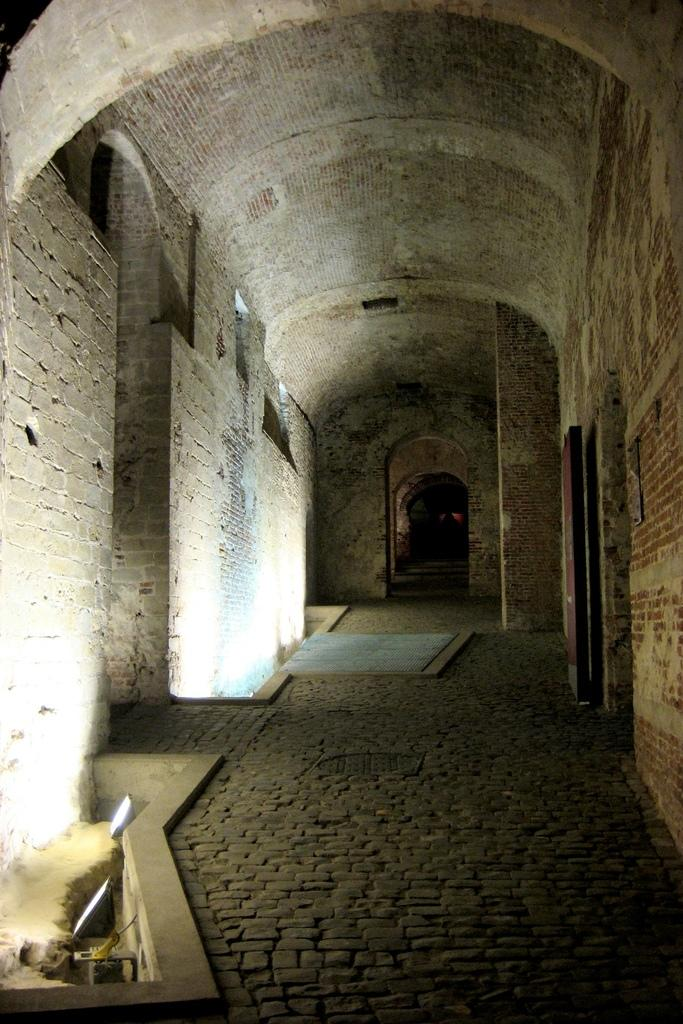What type of structure can be seen in the image? There is an arch in the image. How many stems can be seen growing from the arch in the image? There are no stems growing from the arch in the image, as it is a structure and not a plant. Who is the writer of the book depicted on the arch in the image? There is no book or writer depicted on the arch in the image; it is a standalone structure. 